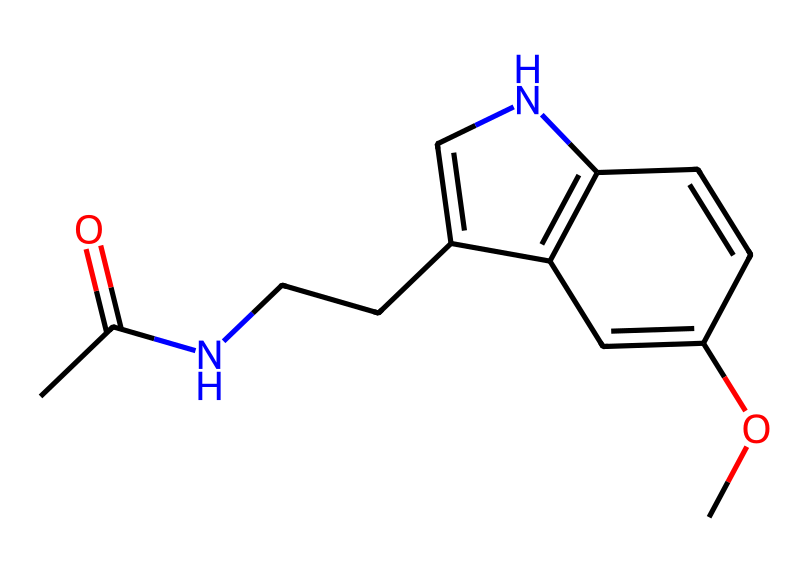What is the molecular formula of melatonin? To determine the molecular formula, we count the number of each type of atom present in the structure: there are 13 carbon atoms, 16 hydrogen atoms, 2 nitrogen atoms, and 2 oxygen atoms. Thus, the formula is C13H16N2O2.
Answer: C13H16N2O2 How many rings are present in the structure of melatonin? By closely examining the provided structure, we can identify two fused rings in the molecule, which are indicated by the connections between atoms that form cyclic structures.
Answer: 2 What type of chemical structure does melatonin represent? Melatonin is classified as an indoleamine, a type of compound that includes an indole ring system, which is visible in the structure as the two connected rings that include nitrogen.
Answer: indoleamine What functional groups are present in melatonin? Looking at the structure, we can identify a carbonyl group (C=O) from the acetyl portion and an ether group (C-O-C) from the methoxy portion, both of which characterize its functional behavior.
Answer: carbonyl and ether What is the role of melatonin in the human body? Melatonin primarily regulates sleep-wake cycles (circadian rhythms) and is known to signal the body when it's time to sleep, influenced by light exposure.
Answer: sleep regulator What is the molecular weight of melatonin? Using the molecular formula (C13H16N2O2) and the atomic weights of the constituent atoms (C, H, N, O), we calculate it to be approximately 232.27 g/mol.
Answer: 232.27 g/mol 